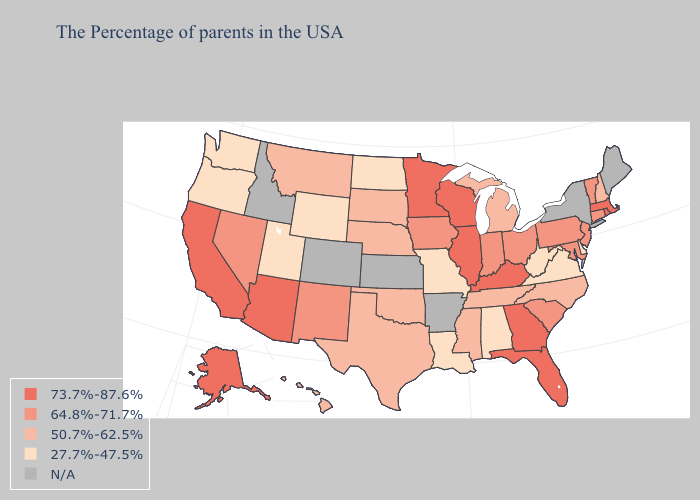Which states have the lowest value in the USA?
Write a very short answer. Delaware, Virginia, West Virginia, Alabama, Louisiana, Missouri, North Dakota, Wyoming, Utah, Washington, Oregon. Name the states that have a value in the range N/A?
Be succinct. Maine, New York, Arkansas, Kansas, Colorado, Idaho. Name the states that have a value in the range 73.7%-87.6%?
Answer briefly. Massachusetts, Rhode Island, Florida, Georgia, Kentucky, Wisconsin, Illinois, Minnesota, Arizona, California, Alaska. What is the value of Missouri?
Keep it brief. 27.7%-47.5%. What is the value of Florida?
Be succinct. 73.7%-87.6%. Does New Hampshire have the lowest value in the Northeast?
Answer briefly. Yes. Does Indiana have the highest value in the USA?
Quick response, please. No. What is the lowest value in the USA?
Write a very short answer. 27.7%-47.5%. Among the states that border Florida , does Georgia have the lowest value?
Answer briefly. No. Does the map have missing data?
Be succinct. Yes. What is the value of Arkansas?
Concise answer only. N/A. What is the value of South Carolina?
Concise answer only. 64.8%-71.7%. What is the value of Tennessee?
Keep it brief. 50.7%-62.5%. Which states have the lowest value in the USA?
Give a very brief answer. Delaware, Virginia, West Virginia, Alabama, Louisiana, Missouri, North Dakota, Wyoming, Utah, Washington, Oregon. 